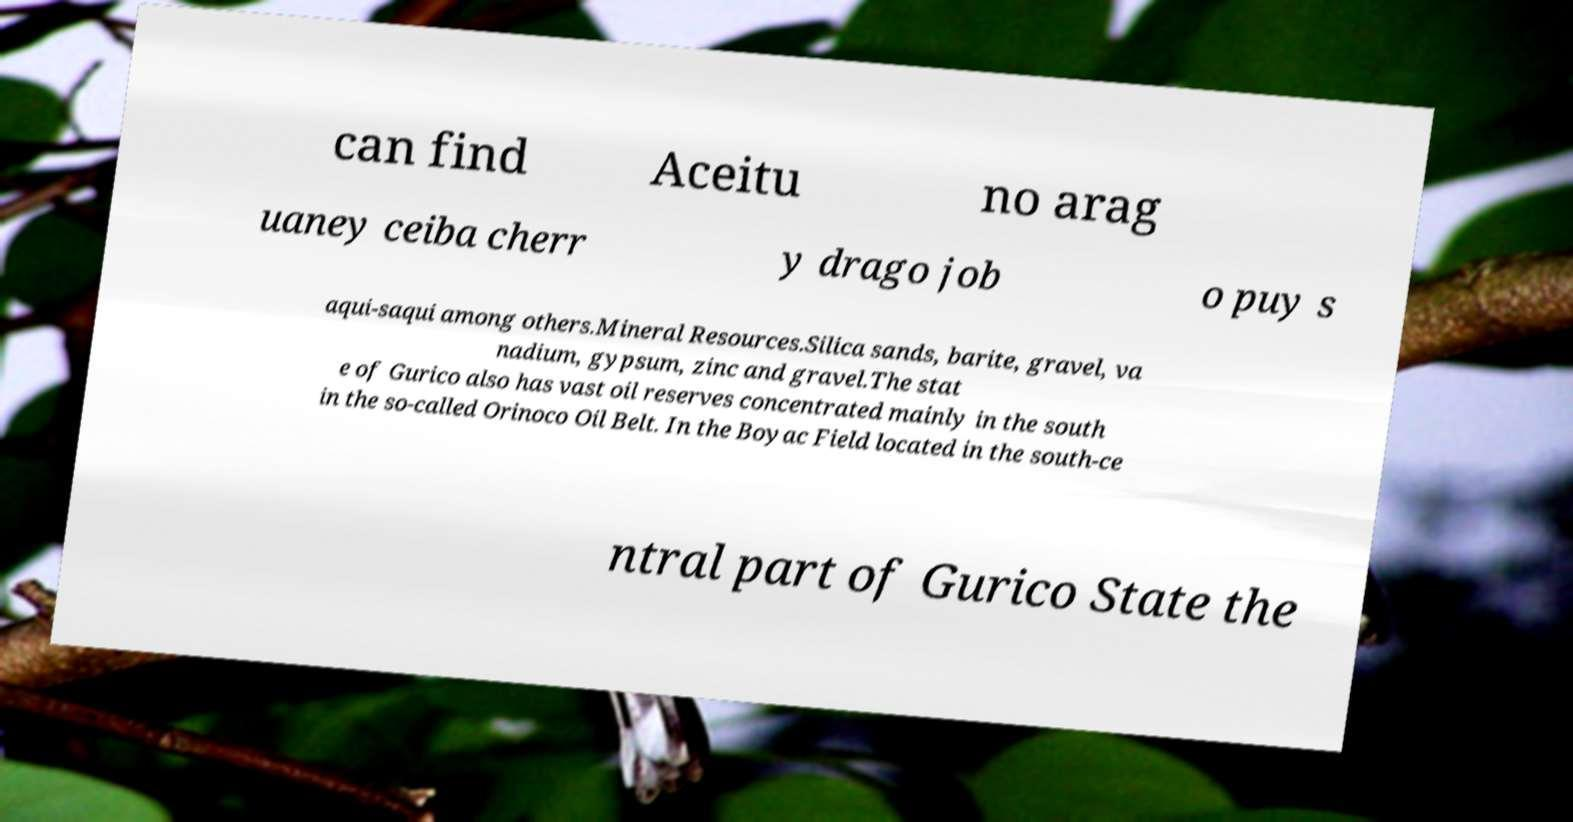Please identify and transcribe the text found in this image. can find Aceitu no arag uaney ceiba cherr y drago job o puy s aqui-saqui among others.Mineral Resources.Silica sands, barite, gravel, va nadium, gypsum, zinc and gravel.The stat e of Gurico also has vast oil reserves concentrated mainly in the south in the so-called Orinoco Oil Belt. In the Boyac Field located in the south-ce ntral part of Gurico State the 